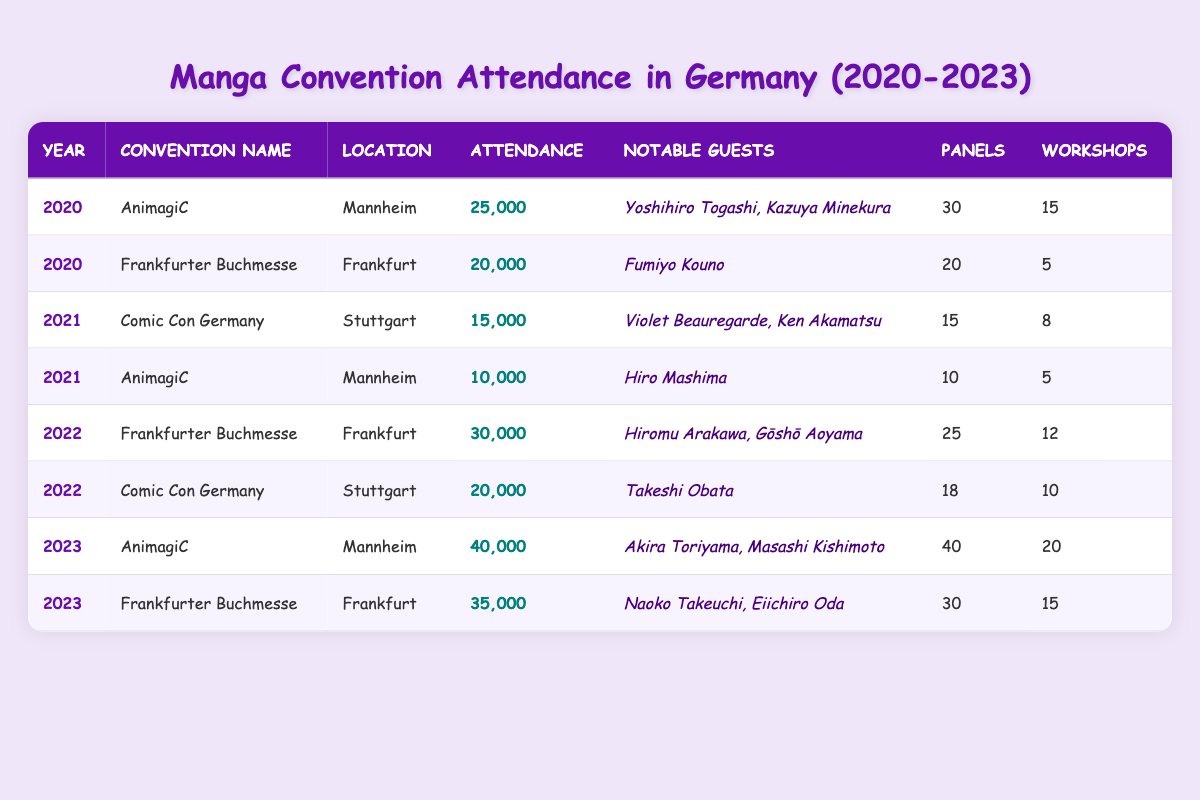What was the highest attendance at a convention from 2020 to 2023? The highest attendance recorded in the table is at AnimagiC in 2023, with 40,000 attendees.
Answer: 40,000 How many notable guests were present at the Frankfurter Buchmesse in 2022? In 2022, the Frankfurter Buchmesse had two notable guests: Hiromu Arakawa and Gōshō Aoyama.
Answer: 2 What year had the least attendance at Comic Con Germany? The least attendance at Comic Con Germany occurred in 2021, with 15,000 attendees.
Answer: 2021 What is the total number of panels held at all conventions in 2023? In 2023, AnimagiC had 40 panels and Frankfurter Buchmesse had 30 panels. The total is 40 + 30 = 70 panels.
Answer: 70 Did the attendance for AnimagiC increase from 2020 to 2023? Yes, attendance at AnimagiC increased from 25,000 in 2020 to 40,000 in 2023.
Answer: Yes What was the average attendance across all conventions in 2022? The total attendance in 2022 is 30,000 (Frankfurter Buchmesse) + 20,000 (Comic Con Germany) = 50,000. Since there are two conventions, the average is 50,000 / 2 = 25,000.
Answer: 25,000 How many more workshops were held at AnimagiC in 2023 compared to 2021? AnimagiC had 20 workshops in 2023 and 5 workshops in 2021. The difference is 20 - 5 = 15 more workshops in 2023.
Answer: 15 Which convention had more panels in 2022: Frankfurter Buchmesse or Comic Con Germany? Frankfurter Buchmesse had 25 panels in 2022, while Comic Con Germany had 18 panels. Therefore, Frankfurter Buchmesse had more.
Answer: Frankfurter Buchmesse What was the overall trend in attendance from 2020 to 2023? Attendance overall increased from 25000 in 2020 to 40000 in 2023, indicating a positive trend.
Answer: Increasing Which year had the highest number of workshops in total? In 2023, there were 20 workshops at AnimagiC and 15 at Frankfurter Buchmesse, which totals 35 workshops. This is the highest compared to any other year.
Answer: 2023 